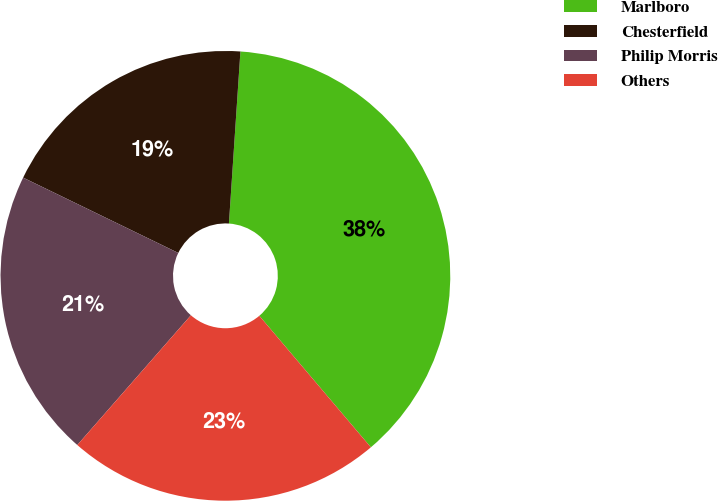<chart> <loc_0><loc_0><loc_500><loc_500><pie_chart><fcel>Marlboro<fcel>Chesterfield<fcel>Philip Morris<fcel>Others<nl><fcel>37.74%<fcel>18.87%<fcel>20.75%<fcel>22.64%<nl></chart> 